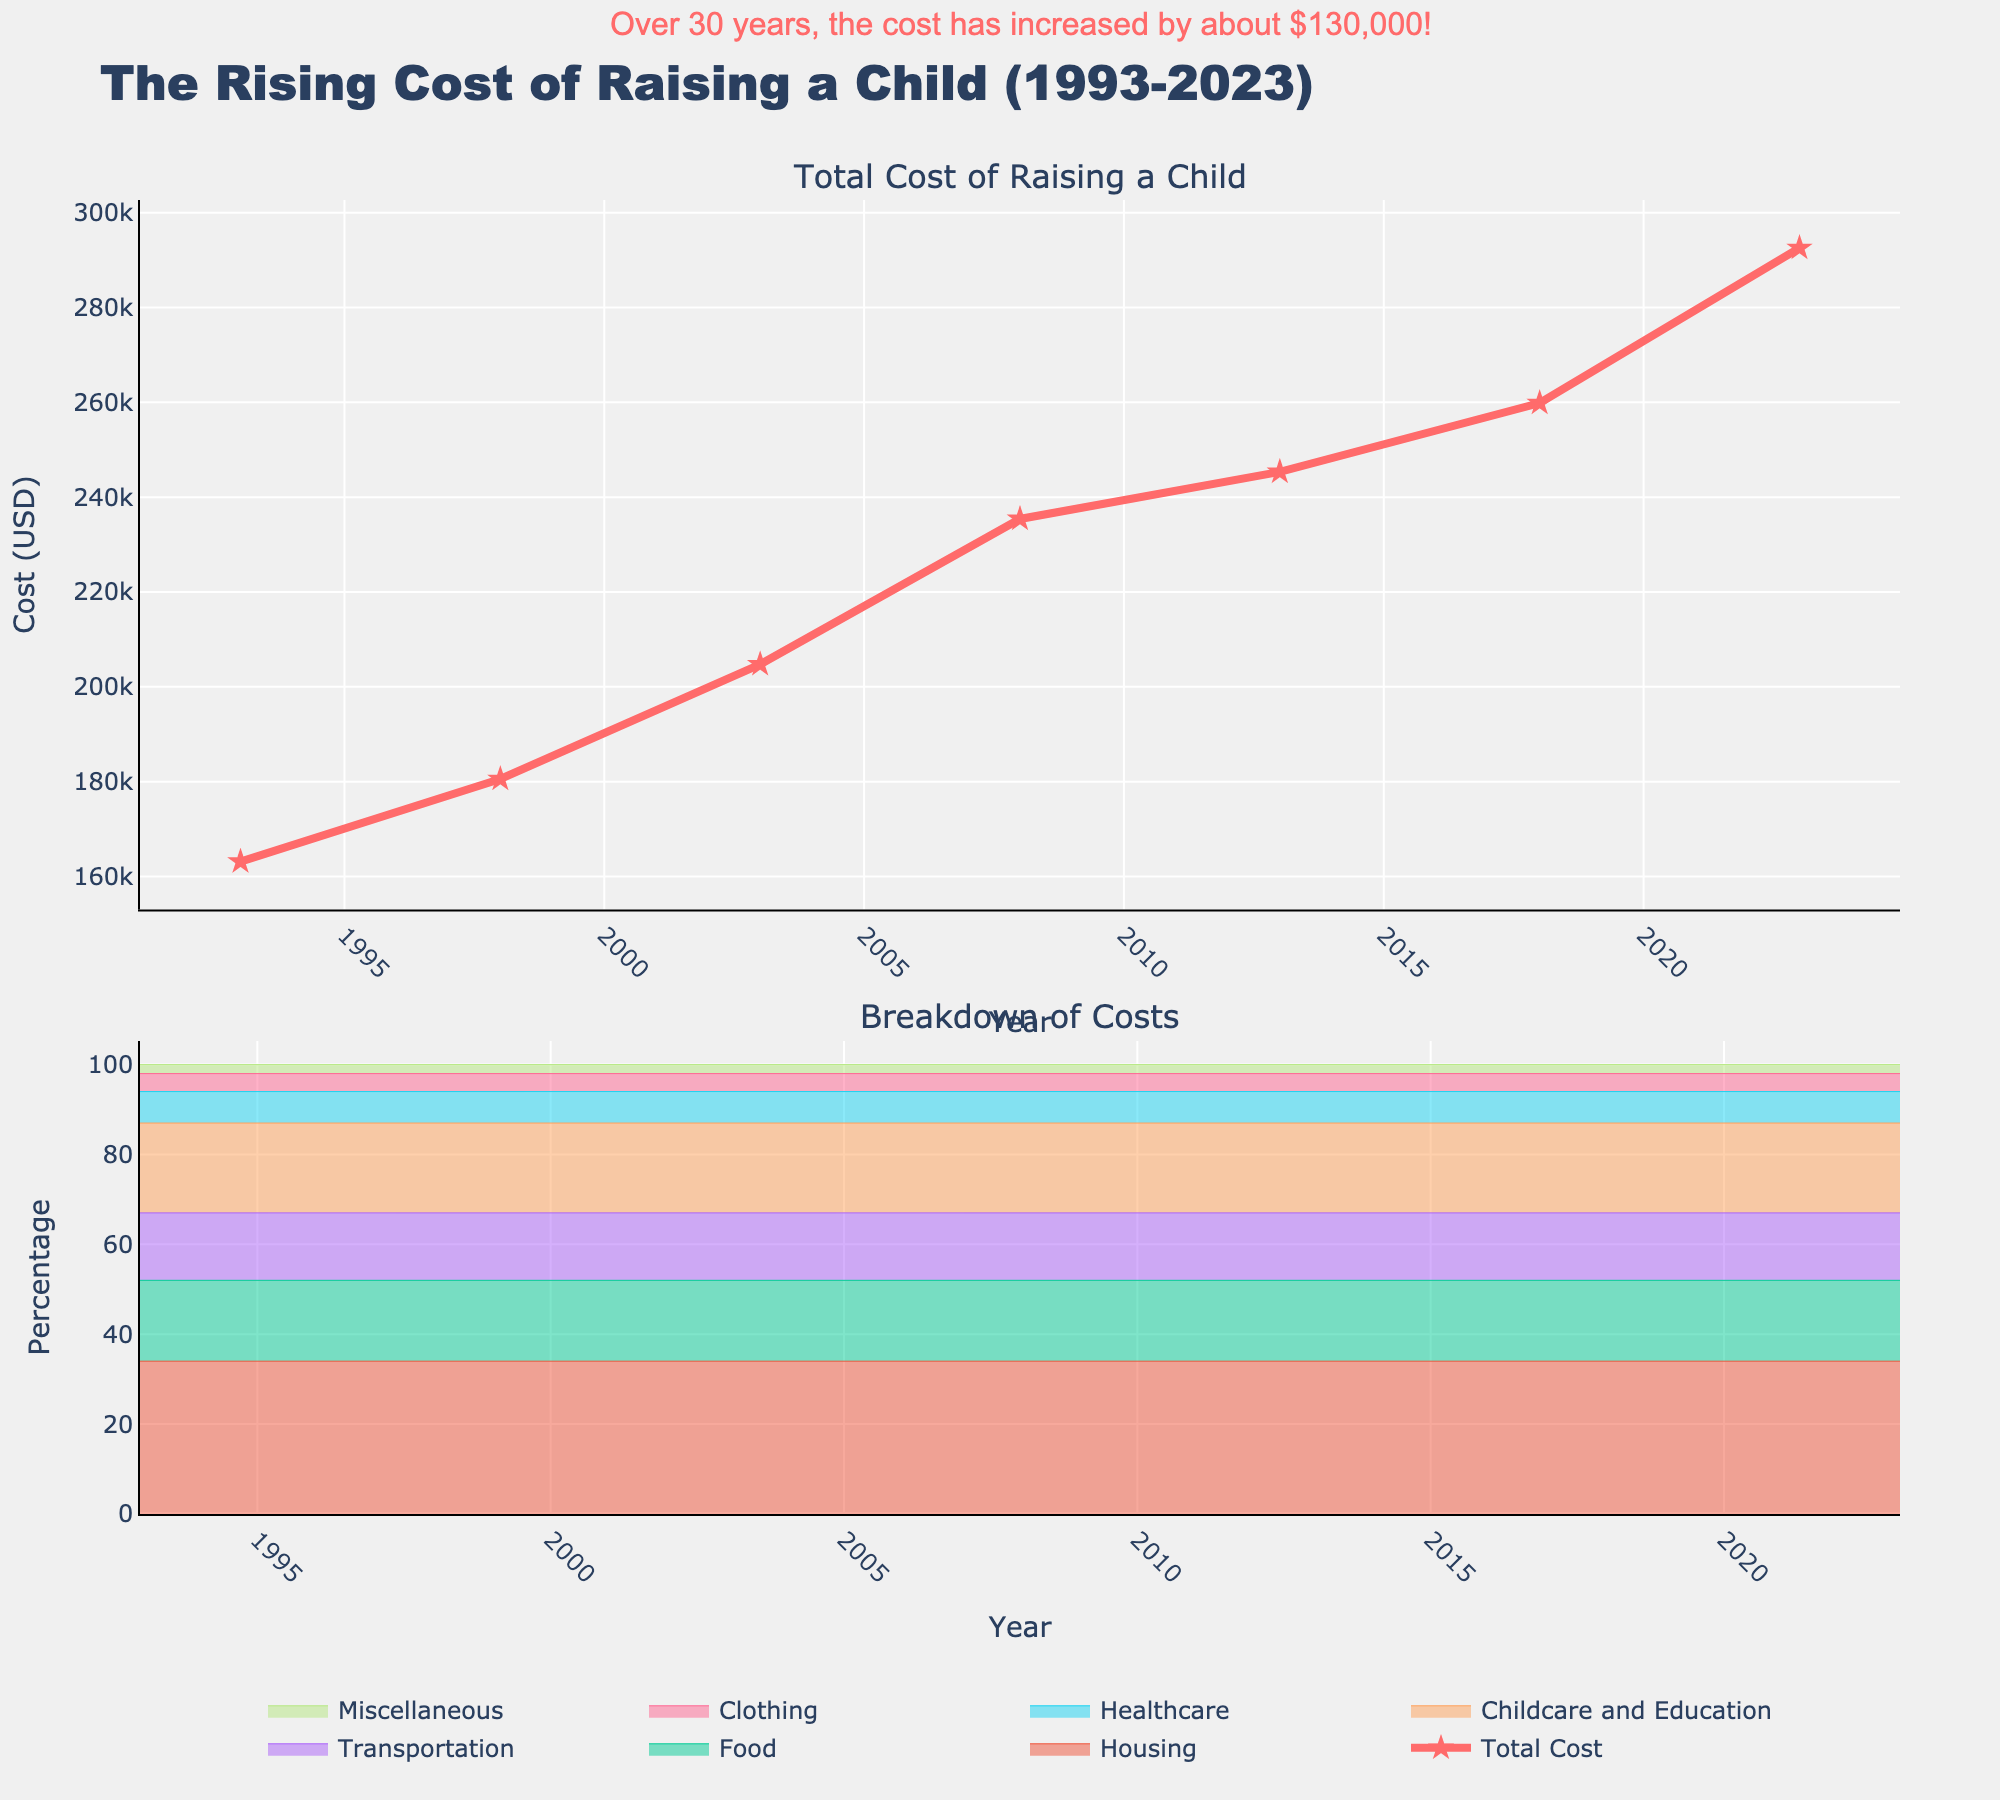Which category shows the highest cost in 2023? Look at the 2023 data in the lower plot. The area for "Housing" is the largest at the top, indicating it has the highest cost.
Answer: Housing What has been the trend in the total cost of raising a child from 1993 to 2023? Examine the "Total Cost" line in the upper plot. The line shows a steady upward trend over the years from 1993 to 2023.
Answer: Increasing By how much has the total cost of raising a child increased from 1993 to 2023? Subtract the total cost in 1993 from the total cost in 2023: 292560 - 163140 = 129420.
Answer: $129,420 Which two categories had the closest cost values in 2003? Compare the values for each category in 2003. "Clothing" and "Miscellaneous" are closest with values of 8190 and 4095 respectively.
Answer: Clothing and Miscellaneous How has the cost of food changed from 1993 to 2023? Find the food costs in 1993 and 2023 and subtract: 52661 - 29365 = 23296.
Answer: Increased by $23,296 Which category has the smallest percentage change over the years? Identify which stack area has the least visual change in height relative to others in the lower plot.
Answer: Miscellaneous Which year saw the highest percentage in healthcare costs? Look at the varying heights of the "Healthcare" area over the years in the lower plot. 2023 appears to have the highest percentage.
Answer: 2023 What is the average cost of transportation over the years shown? Calculate the average by summing the transportation values for all years and divide by the number of years (24471 + 27084 + 30713 + 35312 + 36801 + 38979 + 43884) / 7 = 33877.71
Answer: $33,878 (approx) Between which years did the total cost of raising a child increase the most? By comparing increases year over year, the largest difference is between 2018 and 2023: 292560 - 259860 = 32700.
Answer: 2018-2023 